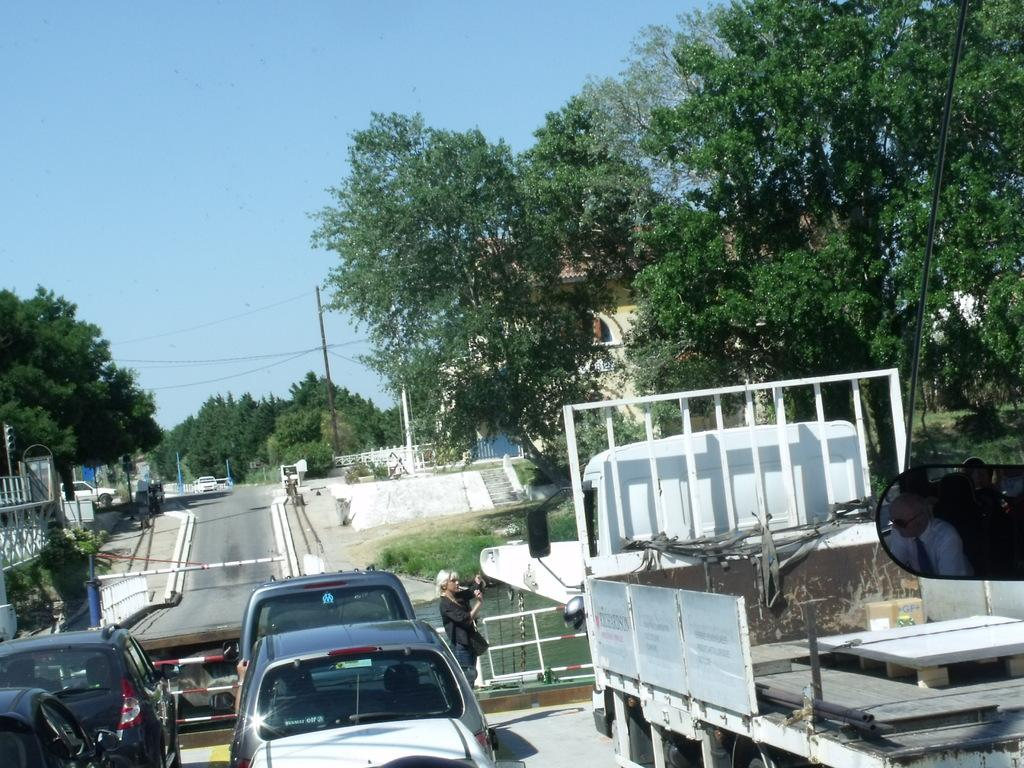What is happening on the road in the image? There are vehicles on the road in the image. Can you describe the woman's position in relation to the vehicles? A woman is in front of the vehicles in the image. What can be seen in the distance behind the vehicles? Water, trees, poles, and buildings are visible in the background of the image. How many elements can be identified in the background of the image? There are four elements present in the background: water, trees, poles, and buildings. Is there a cave visible in the image? No, there is no cave present in the image. What type of hope can be seen in the image? There is no reference to hope in the image, as it features vehicles, a woman, and various background elements. 